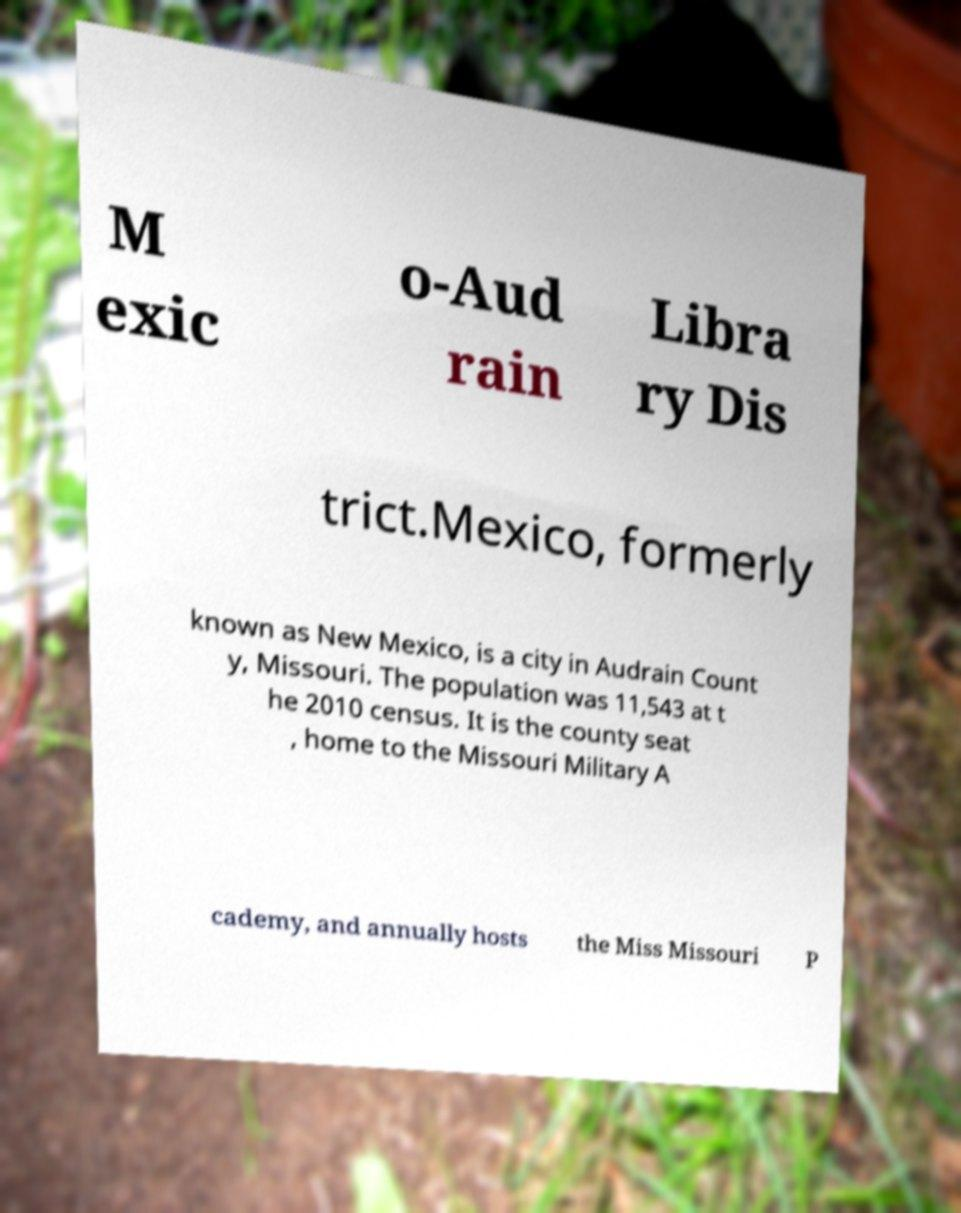Please read and relay the text visible in this image. What does it say? M exic o-Aud rain Libra ry Dis trict.Mexico, formerly known as New Mexico, is a city in Audrain Count y, Missouri. The population was 11,543 at t he 2010 census. It is the county seat , home to the Missouri Military A cademy, and annually hosts the Miss Missouri P 